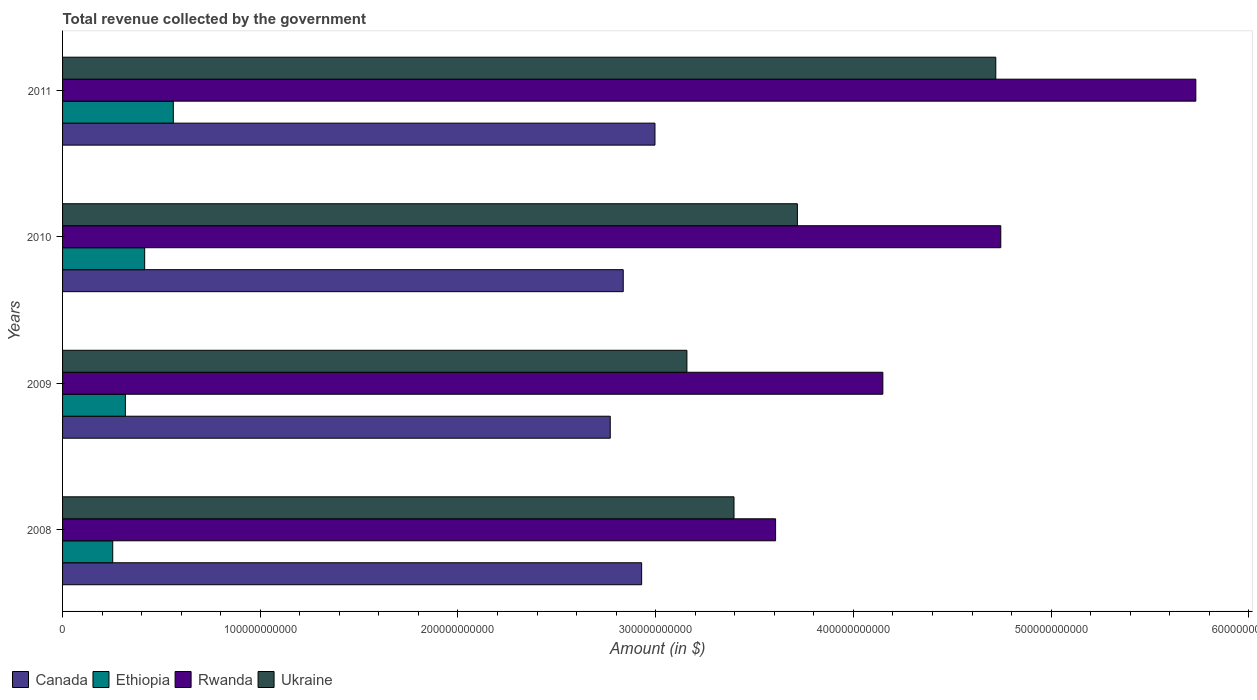How many groups of bars are there?
Ensure brevity in your answer.  4. How many bars are there on the 1st tick from the bottom?
Your response must be concise. 4. In how many cases, is the number of bars for a given year not equal to the number of legend labels?
Ensure brevity in your answer.  0. What is the total revenue collected by the government in Rwanda in 2009?
Your answer should be very brief. 4.15e+11. Across all years, what is the maximum total revenue collected by the government in Ukraine?
Your answer should be very brief. 4.72e+11. Across all years, what is the minimum total revenue collected by the government in Ethiopia?
Your response must be concise. 2.54e+1. In which year was the total revenue collected by the government in Rwanda maximum?
Provide a succinct answer. 2011. In which year was the total revenue collected by the government in Ukraine minimum?
Your response must be concise. 2009. What is the total total revenue collected by the government in Rwanda in the graph?
Your answer should be very brief. 1.82e+12. What is the difference between the total revenue collected by the government in Ukraine in 2009 and that in 2010?
Ensure brevity in your answer.  -5.59e+1. What is the difference between the total revenue collected by the government in Rwanda in 2010 and the total revenue collected by the government in Canada in 2009?
Your answer should be very brief. 1.98e+11. What is the average total revenue collected by the government in Ethiopia per year?
Your response must be concise. 3.87e+1. In the year 2010, what is the difference between the total revenue collected by the government in Ukraine and total revenue collected by the government in Ethiopia?
Provide a succinct answer. 3.30e+11. What is the ratio of the total revenue collected by the government in Ukraine in 2008 to that in 2011?
Your response must be concise. 0.72. Is the difference between the total revenue collected by the government in Ukraine in 2009 and 2010 greater than the difference between the total revenue collected by the government in Ethiopia in 2009 and 2010?
Ensure brevity in your answer.  No. What is the difference between the highest and the second highest total revenue collected by the government in Canada?
Offer a very short reply. 6.74e+09. What is the difference between the highest and the lowest total revenue collected by the government in Ukraine?
Ensure brevity in your answer.  1.56e+11. Is the sum of the total revenue collected by the government in Ethiopia in 2008 and 2011 greater than the maximum total revenue collected by the government in Ukraine across all years?
Ensure brevity in your answer.  No. Is it the case that in every year, the sum of the total revenue collected by the government in Ethiopia and total revenue collected by the government in Ukraine is greater than the sum of total revenue collected by the government in Canada and total revenue collected by the government in Rwanda?
Make the answer very short. Yes. What does the 2nd bar from the top in 2008 represents?
Make the answer very short. Rwanda. What does the 4th bar from the bottom in 2010 represents?
Give a very brief answer. Ukraine. How many bars are there?
Keep it short and to the point. 16. Are all the bars in the graph horizontal?
Your answer should be very brief. Yes. What is the difference between two consecutive major ticks on the X-axis?
Ensure brevity in your answer.  1.00e+11. Are the values on the major ticks of X-axis written in scientific E-notation?
Your answer should be compact. No. Does the graph contain any zero values?
Provide a short and direct response. No. Does the graph contain grids?
Your answer should be compact. No. Where does the legend appear in the graph?
Give a very brief answer. Bottom left. What is the title of the graph?
Your answer should be compact. Total revenue collected by the government. Does "Cuba" appear as one of the legend labels in the graph?
Offer a terse response. No. What is the label or title of the X-axis?
Your answer should be very brief. Amount (in $). What is the Amount (in $) in Canada in 2008?
Your response must be concise. 2.93e+11. What is the Amount (in $) in Ethiopia in 2008?
Your response must be concise. 2.54e+1. What is the Amount (in $) in Rwanda in 2008?
Keep it short and to the point. 3.61e+11. What is the Amount (in $) of Ukraine in 2008?
Provide a short and direct response. 3.40e+11. What is the Amount (in $) in Canada in 2009?
Your response must be concise. 2.77e+11. What is the Amount (in $) in Ethiopia in 2009?
Offer a very short reply. 3.18e+1. What is the Amount (in $) in Rwanda in 2009?
Provide a short and direct response. 4.15e+11. What is the Amount (in $) in Ukraine in 2009?
Your response must be concise. 3.16e+11. What is the Amount (in $) in Canada in 2010?
Your answer should be very brief. 2.84e+11. What is the Amount (in $) in Ethiopia in 2010?
Ensure brevity in your answer.  4.15e+1. What is the Amount (in $) of Rwanda in 2010?
Provide a short and direct response. 4.75e+11. What is the Amount (in $) of Ukraine in 2010?
Your answer should be compact. 3.72e+11. What is the Amount (in $) of Canada in 2011?
Provide a short and direct response. 3.00e+11. What is the Amount (in $) of Ethiopia in 2011?
Provide a succinct answer. 5.60e+1. What is the Amount (in $) of Rwanda in 2011?
Ensure brevity in your answer.  5.73e+11. What is the Amount (in $) of Ukraine in 2011?
Offer a terse response. 4.72e+11. Across all years, what is the maximum Amount (in $) of Canada?
Your answer should be compact. 3.00e+11. Across all years, what is the maximum Amount (in $) of Ethiopia?
Offer a very short reply. 5.60e+1. Across all years, what is the maximum Amount (in $) in Rwanda?
Provide a short and direct response. 5.73e+11. Across all years, what is the maximum Amount (in $) of Ukraine?
Your response must be concise. 4.72e+11. Across all years, what is the minimum Amount (in $) of Canada?
Offer a very short reply. 2.77e+11. Across all years, what is the minimum Amount (in $) of Ethiopia?
Give a very brief answer. 2.54e+1. Across all years, what is the minimum Amount (in $) in Rwanda?
Your answer should be compact. 3.61e+11. Across all years, what is the minimum Amount (in $) of Ukraine?
Your answer should be very brief. 3.16e+11. What is the total Amount (in $) of Canada in the graph?
Make the answer very short. 1.15e+12. What is the total Amount (in $) in Ethiopia in the graph?
Give a very brief answer. 1.55e+11. What is the total Amount (in $) of Rwanda in the graph?
Your answer should be very brief. 1.82e+12. What is the total Amount (in $) in Ukraine in the graph?
Give a very brief answer. 1.50e+12. What is the difference between the Amount (in $) of Canada in 2008 and that in 2009?
Provide a short and direct response. 1.59e+1. What is the difference between the Amount (in $) of Ethiopia in 2008 and that in 2009?
Offer a very short reply. -6.40e+09. What is the difference between the Amount (in $) of Rwanda in 2008 and that in 2009?
Your response must be concise. -5.42e+1. What is the difference between the Amount (in $) in Ukraine in 2008 and that in 2009?
Give a very brief answer. 2.38e+1. What is the difference between the Amount (in $) of Canada in 2008 and that in 2010?
Ensure brevity in your answer.  9.31e+09. What is the difference between the Amount (in $) in Ethiopia in 2008 and that in 2010?
Offer a very short reply. -1.61e+1. What is the difference between the Amount (in $) of Rwanda in 2008 and that in 2010?
Make the answer very short. -1.14e+11. What is the difference between the Amount (in $) in Ukraine in 2008 and that in 2010?
Provide a succinct answer. -3.21e+1. What is the difference between the Amount (in $) of Canada in 2008 and that in 2011?
Your response must be concise. -6.74e+09. What is the difference between the Amount (in $) of Ethiopia in 2008 and that in 2011?
Provide a succinct answer. -3.06e+1. What is the difference between the Amount (in $) in Rwanda in 2008 and that in 2011?
Offer a very short reply. -2.13e+11. What is the difference between the Amount (in $) of Ukraine in 2008 and that in 2011?
Offer a very short reply. -1.32e+11. What is the difference between the Amount (in $) of Canada in 2009 and that in 2010?
Give a very brief answer. -6.57e+09. What is the difference between the Amount (in $) in Ethiopia in 2009 and that in 2010?
Keep it short and to the point. -9.75e+09. What is the difference between the Amount (in $) of Rwanda in 2009 and that in 2010?
Your answer should be very brief. -5.97e+1. What is the difference between the Amount (in $) in Ukraine in 2009 and that in 2010?
Provide a short and direct response. -5.59e+1. What is the difference between the Amount (in $) of Canada in 2009 and that in 2011?
Provide a succinct answer. -2.26e+1. What is the difference between the Amount (in $) in Ethiopia in 2009 and that in 2011?
Offer a very short reply. -2.42e+1. What is the difference between the Amount (in $) in Rwanda in 2009 and that in 2011?
Keep it short and to the point. -1.58e+11. What is the difference between the Amount (in $) of Ukraine in 2009 and that in 2011?
Make the answer very short. -1.56e+11. What is the difference between the Amount (in $) of Canada in 2010 and that in 2011?
Offer a very short reply. -1.60e+1. What is the difference between the Amount (in $) of Ethiopia in 2010 and that in 2011?
Offer a terse response. -1.45e+1. What is the difference between the Amount (in $) in Rwanda in 2010 and that in 2011?
Your response must be concise. -9.87e+1. What is the difference between the Amount (in $) of Ukraine in 2010 and that in 2011?
Your answer should be very brief. -1.00e+11. What is the difference between the Amount (in $) of Canada in 2008 and the Amount (in $) of Ethiopia in 2009?
Keep it short and to the point. 2.61e+11. What is the difference between the Amount (in $) in Canada in 2008 and the Amount (in $) in Rwanda in 2009?
Keep it short and to the point. -1.22e+11. What is the difference between the Amount (in $) in Canada in 2008 and the Amount (in $) in Ukraine in 2009?
Ensure brevity in your answer.  -2.29e+1. What is the difference between the Amount (in $) of Ethiopia in 2008 and the Amount (in $) of Rwanda in 2009?
Your response must be concise. -3.90e+11. What is the difference between the Amount (in $) in Ethiopia in 2008 and the Amount (in $) in Ukraine in 2009?
Make the answer very short. -2.90e+11. What is the difference between the Amount (in $) of Rwanda in 2008 and the Amount (in $) of Ukraine in 2009?
Your response must be concise. 4.49e+1. What is the difference between the Amount (in $) in Canada in 2008 and the Amount (in $) in Ethiopia in 2010?
Your answer should be compact. 2.51e+11. What is the difference between the Amount (in $) of Canada in 2008 and the Amount (in $) of Rwanda in 2010?
Your answer should be compact. -1.82e+11. What is the difference between the Amount (in $) of Canada in 2008 and the Amount (in $) of Ukraine in 2010?
Your answer should be very brief. -7.88e+1. What is the difference between the Amount (in $) of Ethiopia in 2008 and the Amount (in $) of Rwanda in 2010?
Offer a terse response. -4.49e+11. What is the difference between the Amount (in $) in Ethiopia in 2008 and the Amount (in $) in Ukraine in 2010?
Provide a short and direct response. -3.46e+11. What is the difference between the Amount (in $) in Rwanda in 2008 and the Amount (in $) in Ukraine in 2010?
Ensure brevity in your answer.  -1.10e+1. What is the difference between the Amount (in $) in Canada in 2008 and the Amount (in $) in Ethiopia in 2011?
Your response must be concise. 2.37e+11. What is the difference between the Amount (in $) in Canada in 2008 and the Amount (in $) in Rwanda in 2011?
Keep it short and to the point. -2.80e+11. What is the difference between the Amount (in $) in Canada in 2008 and the Amount (in $) in Ukraine in 2011?
Provide a short and direct response. -1.79e+11. What is the difference between the Amount (in $) in Ethiopia in 2008 and the Amount (in $) in Rwanda in 2011?
Offer a very short reply. -5.48e+11. What is the difference between the Amount (in $) in Ethiopia in 2008 and the Amount (in $) in Ukraine in 2011?
Offer a terse response. -4.47e+11. What is the difference between the Amount (in $) of Rwanda in 2008 and the Amount (in $) of Ukraine in 2011?
Offer a very short reply. -1.11e+11. What is the difference between the Amount (in $) in Canada in 2009 and the Amount (in $) in Ethiopia in 2010?
Your response must be concise. 2.35e+11. What is the difference between the Amount (in $) of Canada in 2009 and the Amount (in $) of Rwanda in 2010?
Your response must be concise. -1.98e+11. What is the difference between the Amount (in $) in Canada in 2009 and the Amount (in $) in Ukraine in 2010?
Make the answer very short. -9.47e+1. What is the difference between the Amount (in $) of Ethiopia in 2009 and the Amount (in $) of Rwanda in 2010?
Make the answer very short. -4.43e+11. What is the difference between the Amount (in $) in Ethiopia in 2009 and the Amount (in $) in Ukraine in 2010?
Ensure brevity in your answer.  -3.40e+11. What is the difference between the Amount (in $) of Rwanda in 2009 and the Amount (in $) of Ukraine in 2010?
Your answer should be very brief. 4.32e+1. What is the difference between the Amount (in $) of Canada in 2009 and the Amount (in $) of Ethiopia in 2011?
Your response must be concise. 2.21e+11. What is the difference between the Amount (in $) in Canada in 2009 and the Amount (in $) in Rwanda in 2011?
Your answer should be very brief. -2.96e+11. What is the difference between the Amount (in $) in Canada in 2009 and the Amount (in $) in Ukraine in 2011?
Provide a succinct answer. -1.95e+11. What is the difference between the Amount (in $) of Ethiopia in 2009 and the Amount (in $) of Rwanda in 2011?
Make the answer very short. -5.41e+11. What is the difference between the Amount (in $) of Ethiopia in 2009 and the Amount (in $) of Ukraine in 2011?
Give a very brief answer. -4.40e+11. What is the difference between the Amount (in $) in Rwanda in 2009 and the Amount (in $) in Ukraine in 2011?
Provide a short and direct response. -5.71e+1. What is the difference between the Amount (in $) in Canada in 2010 and the Amount (in $) in Ethiopia in 2011?
Provide a succinct answer. 2.28e+11. What is the difference between the Amount (in $) in Canada in 2010 and the Amount (in $) in Rwanda in 2011?
Offer a terse response. -2.90e+11. What is the difference between the Amount (in $) of Canada in 2010 and the Amount (in $) of Ukraine in 2011?
Make the answer very short. -1.88e+11. What is the difference between the Amount (in $) of Ethiopia in 2010 and the Amount (in $) of Rwanda in 2011?
Keep it short and to the point. -5.32e+11. What is the difference between the Amount (in $) of Ethiopia in 2010 and the Amount (in $) of Ukraine in 2011?
Give a very brief answer. -4.30e+11. What is the difference between the Amount (in $) of Rwanda in 2010 and the Amount (in $) of Ukraine in 2011?
Provide a short and direct response. 2.53e+09. What is the average Amount (in $) in Canada per year?
Give a very brief answer. 2.88e+11. What is the average Amount (in $) of Ethiopia per year?
Give a very brief answer. 3.87e+1. What is the average Amount (in $) in Rwanda per year?
Give a very brief answer. 4.56e+11. What is the average Amount (in $) of Ukraine per year?
Your answer should be compact. 3.75e+11. In the year 2008, what is the difference between the Amount (in $) of Canada and Amount (in $) of Ethiopia?
Provide a succinct answer. 2.68e+11. In the year 2008, what is the difference between the Amount (in $) of Canada and Amount (in $) of Rwanda?
Provide a succinct answer. -6.78e+1. In the year 2008, what is the difference between the Amount (in $) of Canada and Amount (in $) of Ukraine?
Ensure brevity in your answer.  -4.67e+1. In the year 2008, what is the difference between the Amount (in $) of Ethiopia and Amount (in $) of Rwanda?
Provide a short and direct response. -3.35e+11. In the year 2008, what is the difference between the Amount (in $) in Ethiopia and Amount (in $) in Ukraine?
Ensure brevity in your answer.  -3.14e+11. In the year 2008, what is the difference between the Amount (in $) in Rwanda and Amount (in $) in Ukraine?
Offer a very short reply. 2.10e+1. In the year 2009, what is the difference between the Amount (in $) of Canada and Amount (in $) of Ethiopia?
Offer a terse response. 2.45e+11. In the year 2009, what is the difference between the Amount (in $) of Canada and Amount (in $) of Rwanda?
Make the answer very short. -1.38e+11. In the year 2009, what is the difference between the Amount (in $) in Canada and Amount (in $) in Ukraine?
Make the answer very short. -3.88e+1. In the year 2009, what is the difference between the Amount (in $) of Ethiopia and Amount (in $) of Rwanda?
Ensure brevity in your answer.  -3.83e+11. In the year 2009, what is the difference between the Amount (in $) in Ethiopia and Amount (in $) in Ukraine?
Keep it short and to the point. -2.84e+11. In the year 2009, what is the difference between the Amount (in $) of Rwanda and Amount (in $) of Ukraine?
Make the answer very short. 9.91e+1. In the year 2010, what is the difference between the Amount (in $) in Canada and Amount (in $) in Ethiopia?
Offer a terse response. 2.42e+11. In the year 2010, what is the difference between the Amount (in $) in Canada and Amount (in $) in Rwanda?
Your response must be concise. -1.91e+11. In the year 2010, what is the difference between the Amount (in $) of Canada and Amount (in $) of Ukraine?
Keep it short and to the point. -8.81e+1. In the year 2010, what is the difference between the Amount (in $) of Ethiopia and Amount (in $) of Rwanda?
Give a very brief answer. -4.33e+11. In the year 2010, what is the difference between the Amount (in $) of Ethiopia and Amount (in $) of Ukraine?
Ensure brevity in your answer.  -3.30e+11. In the year 2010, what is the difference between the Amount (in $) in Rwanda and Amount (in $) in Ukraine?
Offer a very short reply. 1.03e+11. In the year 2011, what is the difference between the Amount (in $) of Canada and Amount (in $) of Ethiopia?
Your response must be concise. 2.44e+11. In the year 2011, what is the difference between the Amount (in $) in Canada and Amount (in $) in Rwanda?
Keep it short and to the point. -2.74e+11. In the year 2011, what is the difference between the Amount (in $) of Canada and Amount (in $) of Ukraine?
Offer a terse response. -1.72e+11. In the year 2011, what is the difference between the Amount (in $) of Ethiopia and Amount (in $) of Rwanda?
Keep it short and to the point. -5.17e+11. In the year 2011, what is the difference between the Amount (in $) in Ethiopia and Amount (in $) in Ukraine?
Provide a short and direct response. -4.16e+11. In the year 2011, what is the difference between the Amount (in $) of Rwanda and Amount (in $) of Ukraine?
Your response must be concise. 1.01e+11. What is the ratio of the Amount (in $) of Canada in 2008 to that in 2009?
Make the answer very short. 1.06. What is the ratio of the Amount (in $) of Ethiopia in 2008 to that in 2009?
Keep it short and to the point. 0.8. What is the ratio of the Amount (in $) in Rwanda in 2008 to that in 2009?
Make the answer very short. 0.87. What is the ratio of the Amount (in $) in Ukraine in 2008 to that in 2009?
Provide a succinct answer. 1.08. What is the ratio of the Amount (in $) in Canada in 2008 to that in 2010?
Give a very brief answer. 1.03. What is the ratio of the Amount (in $) of Ethiopia in 2008 to that in 2010?
Offer a terse response. 0.61. What is the ratio of the Amount (in $) of Rwanda in 2008 to that in 2010?
Your response must be concise. 0.76. What is the ratio of the Amount (in $) of Ukraine in 2008 to that in 2010?
Your answer should be very brief. 0.91. What is the ratio of the Amount (in $) in Canada in 2008 to that in 2011?
Offer a terse response. 0.98. What is the ratio of the Amount (in $) in Ethiopia in 2008 to that in 2011?
Offer a very short reply. 0.45. What is the ratio of the Amount (in $) of Rwanda in 2008 to that in 2011?
Keep it short and to the point. 0.63. What is the ratio of the Amount (in $) of Ukraine in 2008 to that in 2011?
Give a very brief answer. 0.72. What is the ratio of the Amount (in $) in Canada in 2009 to that in 2010?
Your answer should be very brief. 0.98. What is the ratio of the Amount (in $) of Ethiopia in 2009 to that in 2010?
Offer a terse response. 0.77. What is the ratio of the Amount (in $) of Rwanda in 2009 to that in 2010?
Ensure brevity in your answer.  0.87. What is the ratio of the Amount (in $) in Ukraine in 2009 to that in 2010?
Provide a succinct answer. 0.85. What is the ratio of the Amount (in $) of Canada in 2009 to that in 2011?
Offer a terse response. 0.92. What is the ratio of the Amount (in $) of Ethiopia in 2009 to that in 2011?
Offer a terse response. 0.57. What is the ratio of the Amount (in $) in Rwanda in 2009 to that in 2011?
Ensure brevity in your answer.  0.72. What is the ratio of the Amount (in $) in Ukraine in 2009 to that in 2011?
Offer a very short reply. 0.67. What is the ratio of the Amount (in $) of Canada in 2010 to that in 2011?
Provide a succinct answer. 0.95. What is the ratio of the Amount (in $) in Ethiopia in 2010 to that in 2011?
Provide a succinct answer. 0.74. What is the ratio of the Amount (in $) in Rwanda in 2010 to that in 2011?
Your answer should be very brief. 0.83. What is the ratio of the Amount (in $) in Ukraine in 2010 to that in 2011?
Provide a short and direct response. 0.79. What is the difference between the highest and the second highest Amount (in $) in Canada?
Give a very brief answer. 6.74e+09. What is the difference between the highest and the second highest Amount (in $) of Ethiopia?
Provide a succinct answer. 1.45e+1. What is the difference between the highest and the second highest Amount (in $) in Rwanda?
Your answer should be compact. 9.87e+1. What is the difference between the highest and the second highest Amount (in $) of Ukraine?
Keep it short and to the point. 1.00e+11. What is the difference between the highest and the lowest Amount (in $) in Canada?
Offer a terse response. 2.26e+1. What is the difference between the highest and the lowest Amount (in $) in Ethiopia?
Keep it short and to the point. 3.06e+1. What is the difference between the highest and the lowest Amount (in $) of Rwanda?
Provide a short and direct response. 2.13e+11. What is the difference between the highest and the lowest Amount (in $) in Ukraine?
Offer a terse response. 1.56e+11. 